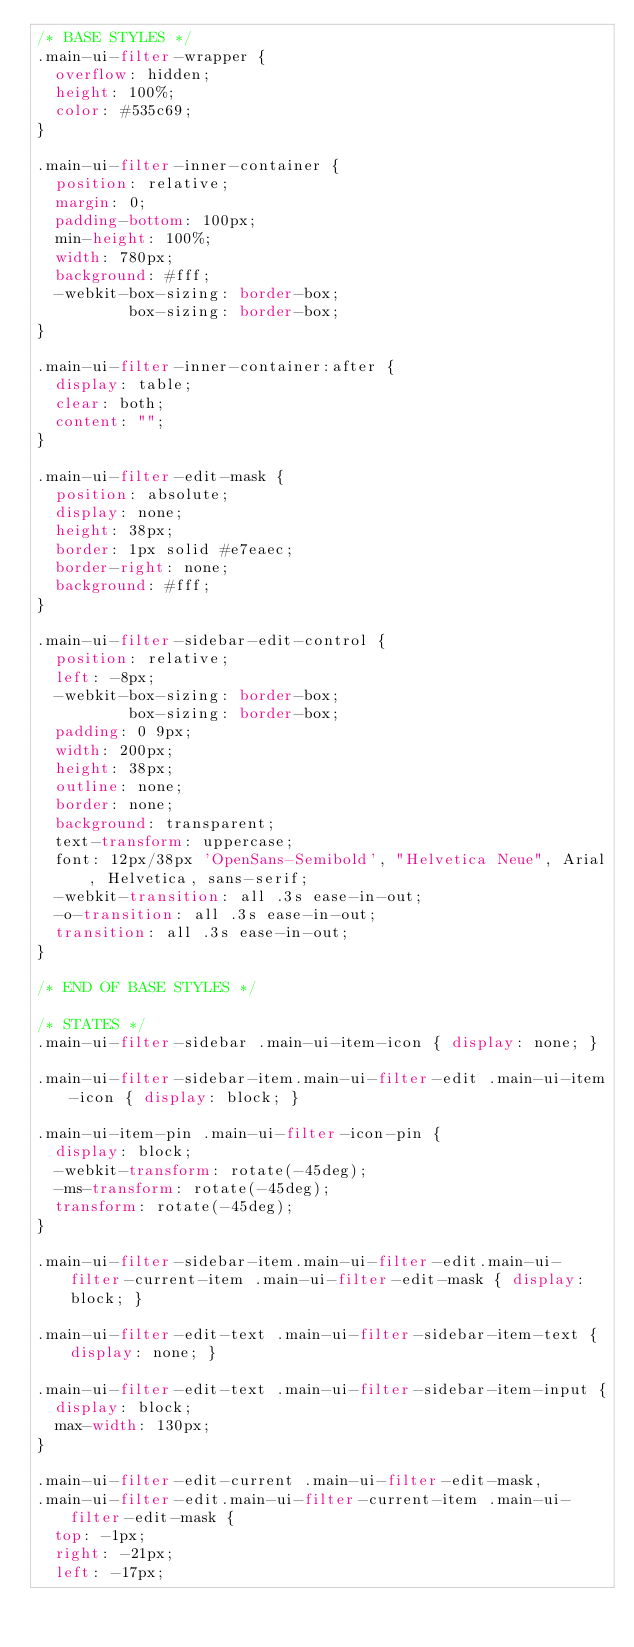Convert code to text. <code><loc_0><loc_0><loc_500><loc_500><_CSS_>/* BASE STYLES */
.main-ui-filter-wrapper {
	overflow: hidden;
	height: 100%;
	color: #535c69;
}

.main-ui-filter-inner-container {
	position: relative;
	margin: 0;
	padding-bottom: 100px;
	min-height: 100%;
	width: 780px;
	background: #fff;
	-webkit-box-sizing: border-box;
	        box-sizing: border-box;
}

.main-ui-filter-inner-container:after {
	display: table;
	clear: both;
	content: "";
}

.main-ui-filter-edit-mask {
	position: absolute;
	display: none;
	height: 38px;
	border: 1px solid #e7eaec;
	border-right: none;
	background: #fff;
}

.main-ui-filter-sidebar-edit-control {
	position: relative;
	left: -8px;
	-webkit-box-sizing: border-box;
	        box-sizing: border-box;
	padding: 0 9px;
	width: 200px;
	height: 38px;
	outline: none;
	border: none;
	background: transparent;
	text-transform: uppercase;
	font: 12px/38px 'OpenSans-Semibold', "Helvetica Neue", Arial, Helvetica, sans-serif;
	-webkit-transition: all .3s ease-in-out;
	-o-transition: all .3s ease-in-out;
	transition: all .3s ease-in-out;
}

/* END OF BASE STYLES */

/* STATES */
.main-ui-filter-sidebar .main-ui-item-icon { display: none; }

.main-ui-filter-sidebar-item.main-ui-filter-edit .main-ui-item-icon { display: block; }

.main-ui-item-pin .main-ui-filter-icon-pin {
	display: block;
	-webkit-transform: rotate(-45deg);
	-ms-transform: rotate(-45deg);
	transform: rotate(-45deg);
}

.main-ui-filter-sidebar-item.main-ui-filter-edit.main-ui-filter-current-item .main-ui-filter-edit-mask { display: block; }

.main-ui-filter-edit-text .main-ui-filter-sidebar-item-text { display: none; }

.main-ui-filter-edit-text .main-ui-filter-sidebar-item-input {
	display: block;
	max-width: 130px;
}

.main-ui-filter-edit-current .main-ui-filter-edit-mask,
.main-ui-filter-edit.main-ui-filter-current-item .main-ui-filter-edit-mask {
	top: -1px;
	right: -21px;
	left: -17px;</code> 